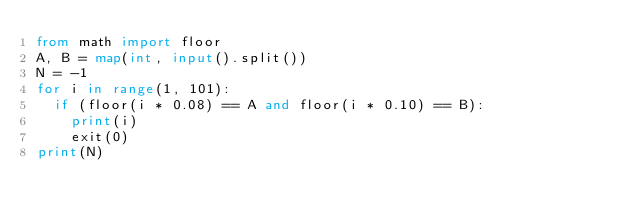<code> <loc_0><loc_0><loc_500><loc_500><_Python_>from math import floor
A, B = map(int, input().split())
N = -1
for i in range(1, 101):
  if (floor(i * 0.08) == A and floor(i * 0.10) == B):
    print(i)
    exit(0)
print(N)</code> 